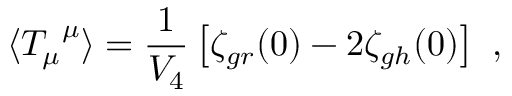Convert formula to latex. <formula><loc_0><loc_0><loc_500><loc_500>\langle { T _ { \mu } } ^ { \mu } \rangle = \frac { 1 } { V _ { 4 } } \left [ \zeta _ { g r } ( 0 ) - 2 \zeta _ { g h } ( 0 ) \right ] \ ,</formula> 